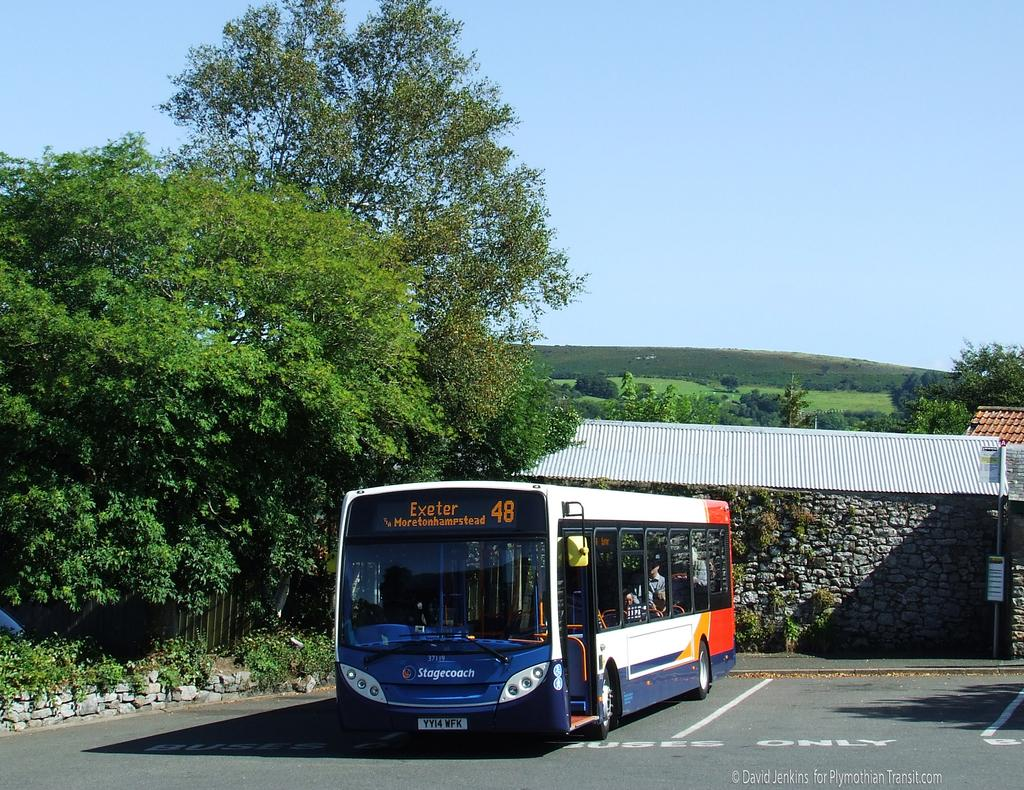What type of vegetation can be seen in the image? There are trees in the image. What mode of transportation is present in the image? There is a bus in the image. What type of structures are visible in the image? There are houses in the image. What type of ground surface is visible in the image? There is grass visible in the image. What part of the natural environment is visible in the image? The sky is visible in the image. Are there any dinosaurs visible in the image? No, there are no dinosaurs present in the image. What type of vessel is being used for the trip in the image? There is no trip or vessel present in the image; it features a bus, houses, trees, grass, and the sky. 